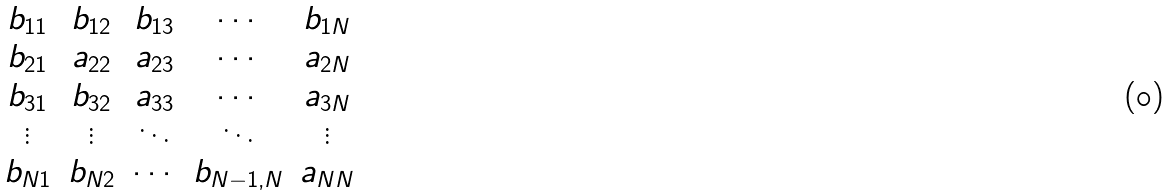Convert formula to latex. <formula><loc_0><loc_0><loc_500><loc_500>\begin{matrix} b _ { 1 1 } & b _ { 1 2 } & b _ { 1 3 } & \cdots & b _ { 1 N } \\ b _ { 2 1 } & a _ { 2 2 } & a _ { 2 3 } & \cdots & a _ { 2 N } \\ b _ { 3 1 } & b _ { 3 2 } & a _ { 3 3 } & \cdots & a _ { 3 N } \\ \vdots & \vdots & \ddots & \ddots & \vdots \\ b _ { N 1 } & b _ { N 2 } & \cdots & b _ { N - 1 , N } & a _ { N N } \end{matrix}</formula> 